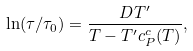<formula> <loc_0><loc_0><loc_500><loc_500>\ln ( \tau / \tau _ { 0 } ) = \frac { D T ^ { \prime } } { T - T ^ { \prime } c _ { P } ^ { c } ( T ) } ,</formula> 